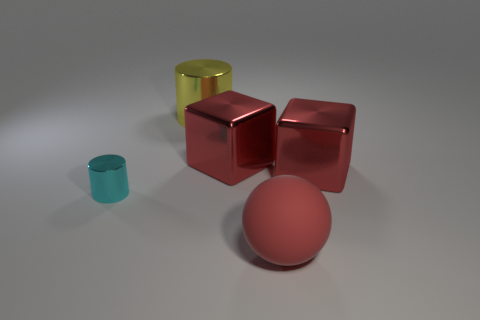Are there any large objects of the same shape as the small cyan metal thing?
Your response must be concise. Yes. There is a cyan metallic cylinder; does it have the same size as the metal cylinder behind the cyan cylinder?
Keep it short and to the point. No. What number of objects are things that are behind the small cyan object or rubber objects to the right of the yellow cylinder?
Give a very brief answer. 4. Are there more cylinders in front of the large red matte object than tiny blue metallic balls?
Offer a very short reply. No. What number of red metal things have the same size as the rubber thing?
Keep it short and to the point. 2. There is a sphere that is to the right of the tiny cyan cylinder; does it have the same size as the object that is on the right side of the large red rubber ball?
Give a very brief answer. Yes. There is a red metal cube on the right side of the big red matte object; how big is it?
Provide a succinct answer. Large. There is a red object in front of the object that is to the left of the yellow metallic cylinder; how big is it?
Your response must be concise. Large. What is the material of the sphere that is the same size as the yellow metallic object?
Your answer should be compact. Rubber. Are there any tiny cyan shiny things on the right side of the large yellow metallic cylinder?
Offer a terse response. No. 